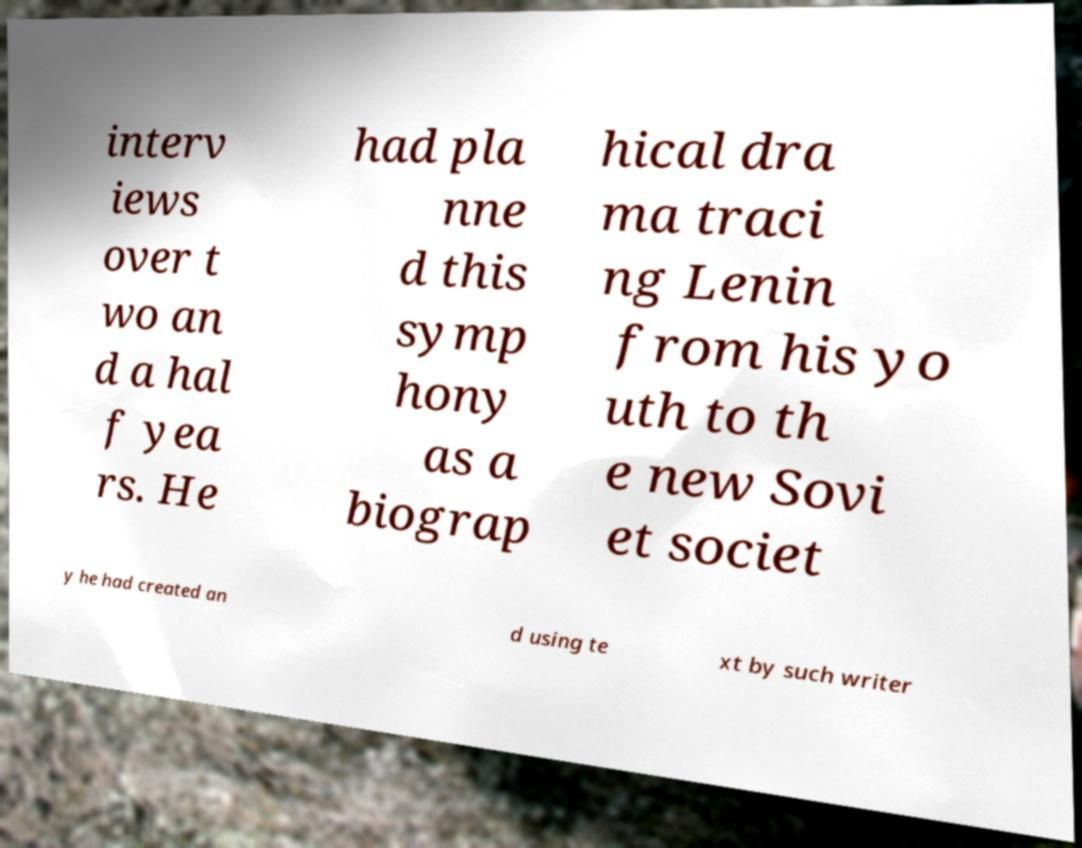Could you extract and type out the text from this image? interv iews over t wo an d a hal f yea rs. He had pla nne d this symp hony as a biograp hical dra ma traci ng Lenin from his yo uth to th e new Sovi et societ y he had created an d using te xt by such writer 